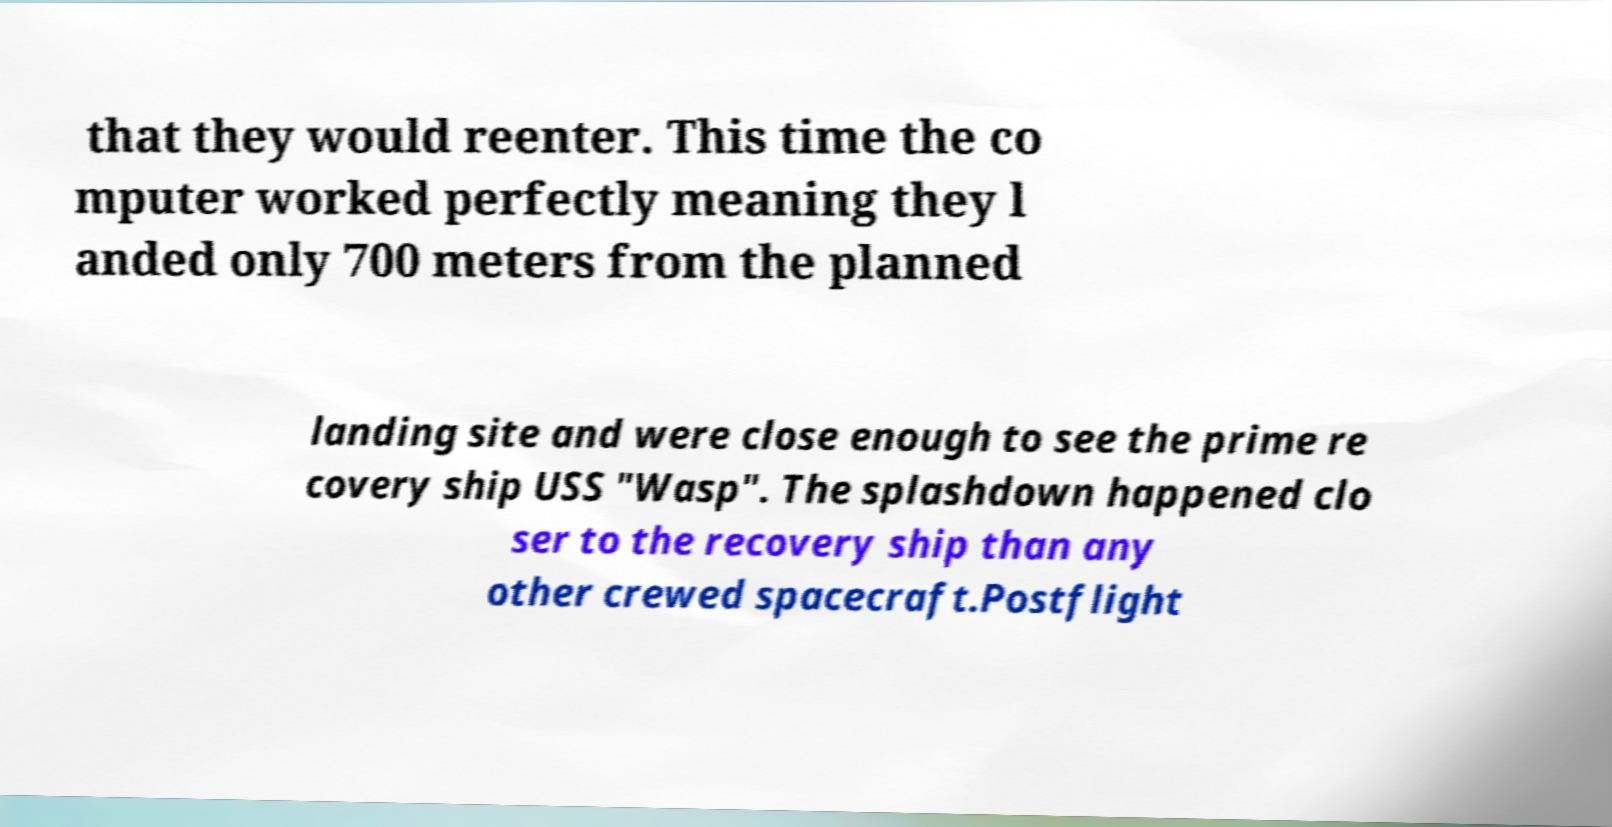Could you assist in decoding the text presented in this image and type it out clearly? that they would reenter. This time the co mputer worked perfectly meaning they l anded only 700 meters from the planned landing site and were close enough to see the prime re covery ship USS "Wasp". The splashdown happened clo ser to the recovery ship than any other crewed spacecraft.Postflight 